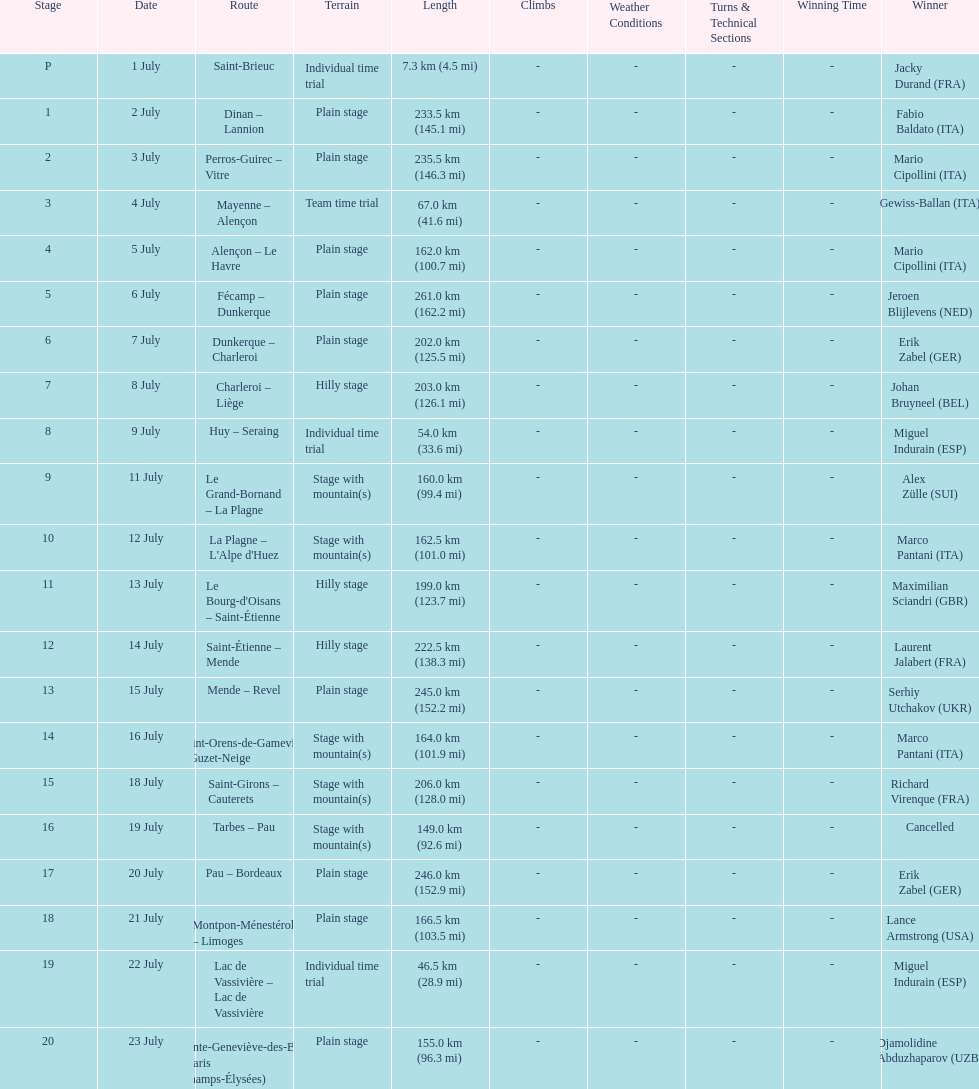After lance armstrong, who led next in the 1995 tour de france? Miguel Indurain. 